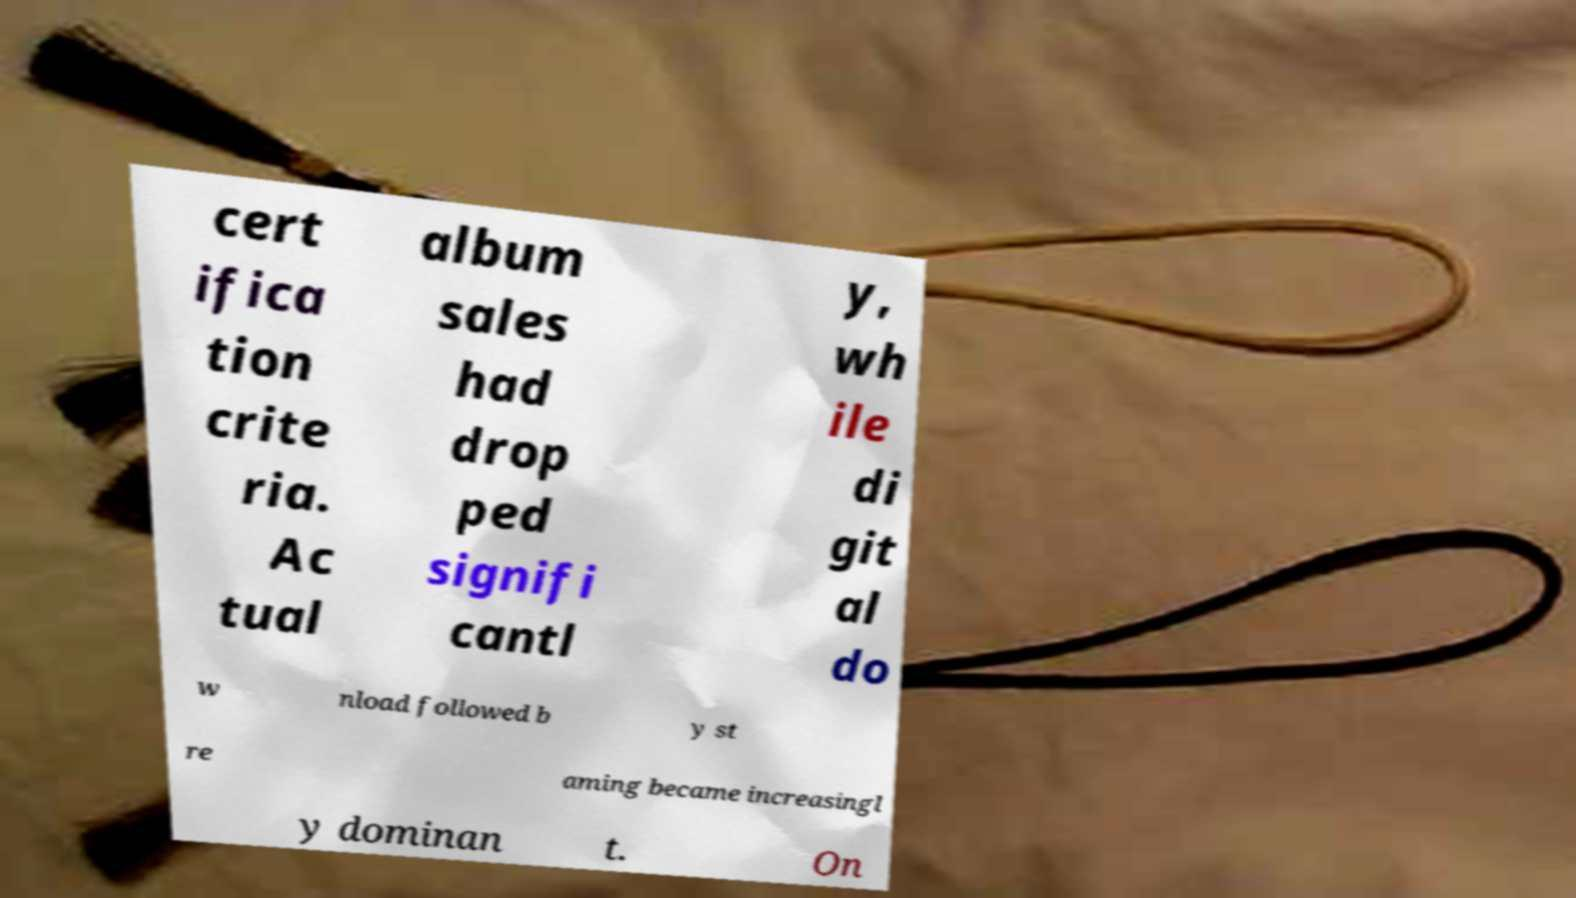Please identify and transcribe the text found in this image. cert ifica tion crite ria. Ac tual album sales had drop ped signifi cantl y, wh ile di git al do w nload followed b y st re aming became increasingl y dominan t. On 